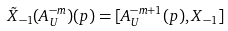<formula> <loc_0><loc_0><loc_500><loc_500>\tilde { X } _ { - 1 } ( A _ { U } ^ { - m } ) ( p ) = [ A _ { U } ^ { - m + 1 } ( p ) , X _ { - 1 } ]</formula> 